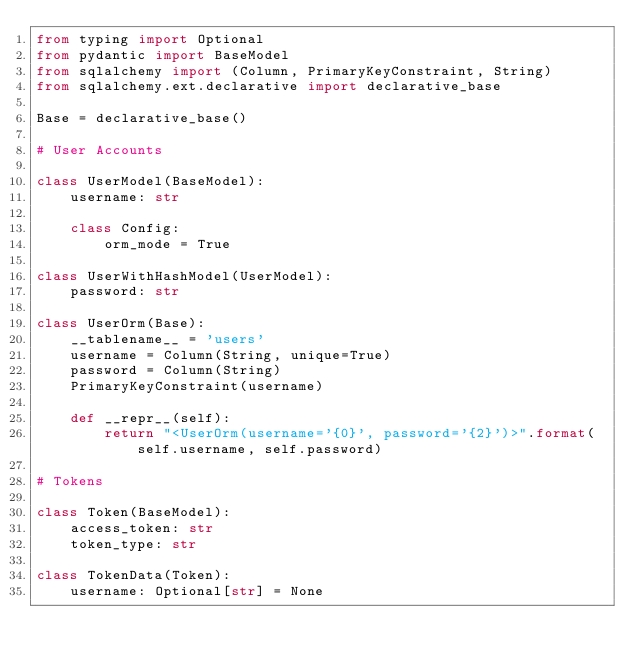Convert code to text. <code><loc_0><loc_0><loc_500><loc_500><_Python_>from typing import Optional
from pydantic import BaseModel
from sqlalchemy import (Column, PrimaryKeyConstraint, String)
from sqlalchemy.ext.declarative import declarative_base

Base = declarative_base()

# User Accounts

class UserModel(BaseModel):
    username: str

    class Config:
        orm_mode = True

class UserWithHashModel(UserModel):
    password: str

class UserOrm(Base):
    __tablename__ = 'users'
    username = Column(String, unique=True)
    password = Column(String)
    PrimaryKeyConstraint(username)

    def __repr__(self):
        return "<UserOrm(username='{0}', password='{2}')>".format(self.username, self.password)

# Tokens

class Token(BaseModel):
    access_token: str
    token_type: str

class TokenData(Token):
    username: Optional[str] = None
</code> 